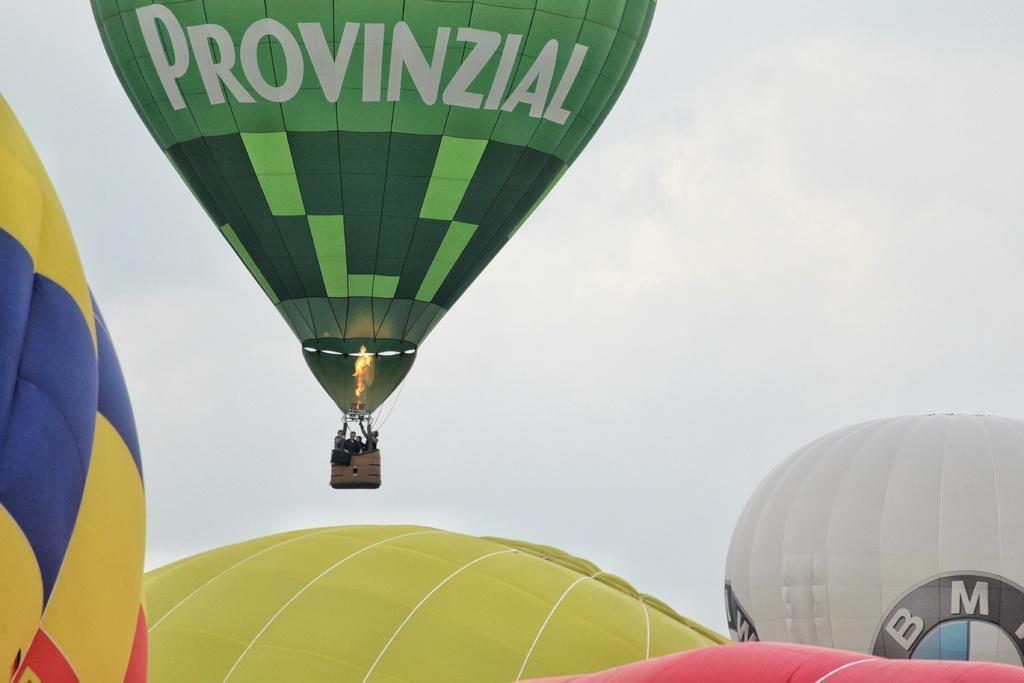Please provide a concise description of this image. In this picture we can see parachutes, here we can see people and we can see sky in the background. 